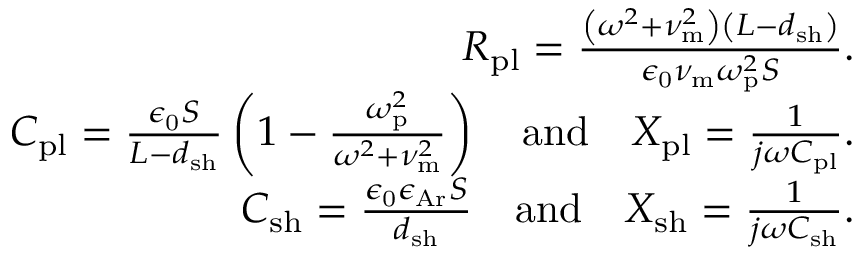Convert formula to latex. <formula><loc_0><loc_0><loc_500><loc_500>\begin{array} { r } { R _ { p l } = \frac { \left ( \omega ^ { 2 } + \nu _ { m } ^ { 2 } \right ) \left ( L - d _ { s h } \right ) } { \epsilon _ { 0 } \nu _ { m } \omega _ { p } ^ { 2 } S } . } \\ { C _ { p l } = \frac { \epsilon _ { 0 } S } { L - d _ { s h } } \left ( 1 - \frac { \omega _ { p } ^ { 2 } } { \omega ^ { 2 } + \nu _ { m } ^ { 2 } } \right ) \quad a n d \quad X _ { p l } = \frac { 1 } { j \omega C _ { p l } } . } \\ { C _ { s h } = \frac { \epsilon _ { 0 } \epsilon _ { A r } S } { d _ { s h } } \quad a n d \quad X _ { s h } = \frac { 1 } { j \omega C _ { s h } } . } \end{array}</formula> 